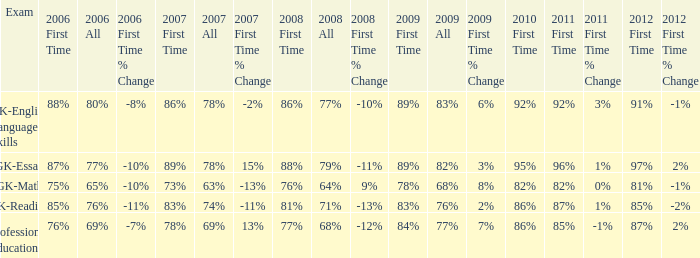What is the percentage for all 2008 when all in 2007 is 69%? 68%. 